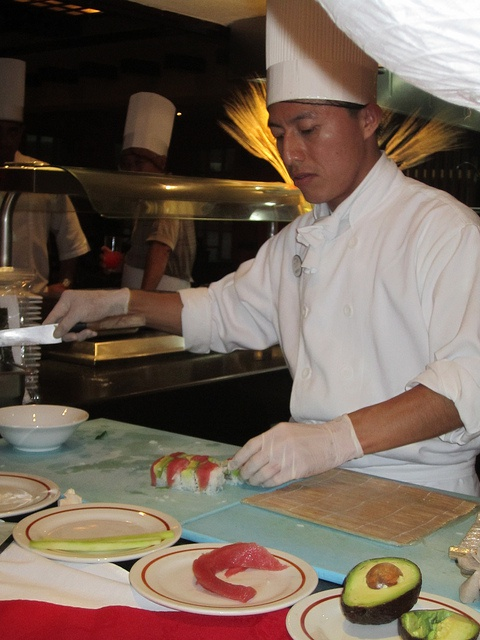Describe the objects in this image and their specific colors. I can see people in black, darkgray, brown, and maroon tones, oven in black, gray, and olive tones, people in black, maroon, and olive tones, people in black, brown, maroon, and gray tones, and bowl in black, darkgray, and gray tones in this image. 